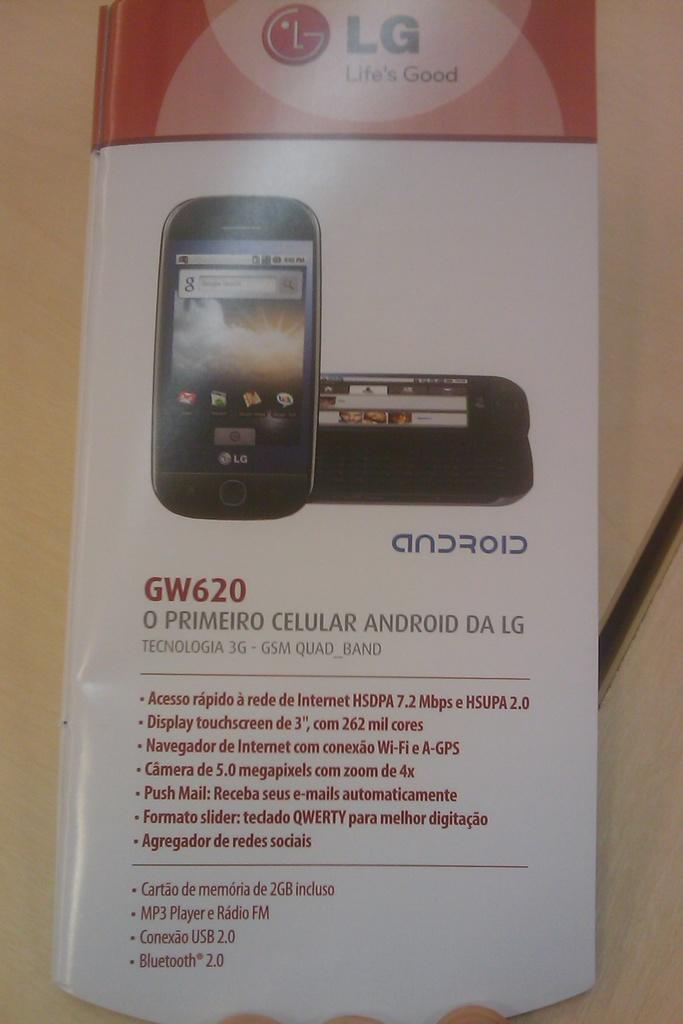Provide a one-sentence caption for the provided image. The box has a picture of the GW620 android cell phone. 